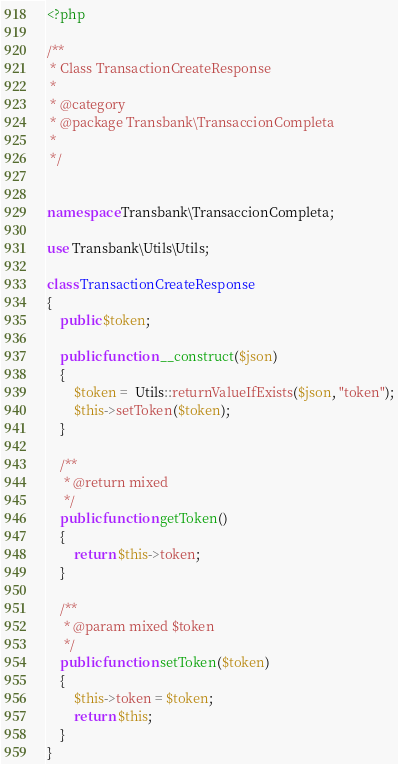Convert code to text. <code><loc_0><loc_0><loc_500><loc_500><_PHP_><?php

/**
 * Class TransactionCreateResponse
 *
 * @category
 * @package Transbank\TransaccionCompleta
 *
 */


namespace Transbank\TransaccionCompleta;

use Transbank\Utils\Utils;

class TransactionCreateResponse
{
    public $token;

    public function __construct($json)
    {
        $token =  Utils::returnValueIfExists($json, "token");
        $this->setToken($token);
    }

    /**
     * @return mixed
     */
    public function getToken()
    {
        return $this->token;
    }

    /**
     * @param mixed $token
     */
    public function setToken($token)
    {
        $this->token = $token;
        return $this;
    }
}
</code> 